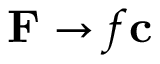<formula> <loc_0><loc_0><loc_500><loc_500>F \rightarrow f c</formula> 